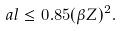Convert formula to latex. <formula><loc_0><loc_0><loc_500><loc_500>\ a l \leq 0 . 8 5 ( \beta Z ) ^ { 2 } .</formula> 